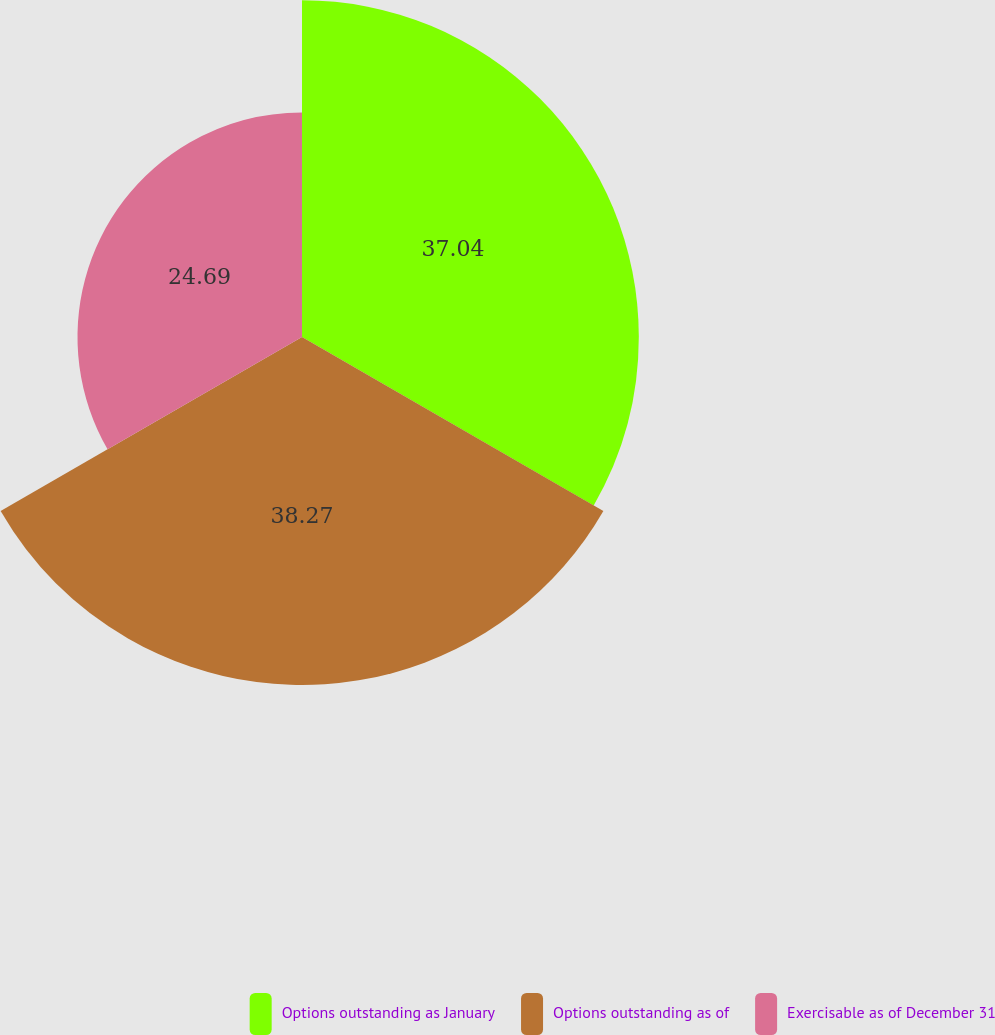Convert chart to OTSL. <chart><loc_0><loc_0><loc_500><loc_500><pie_chart><fcel>Options outstanding as January<fcel>Options outstanding as of<fcel>Exercisable as of December 31<nl><fcel>37.04%<fcel>38.27%<fcel>24.69%<nl></chart> 